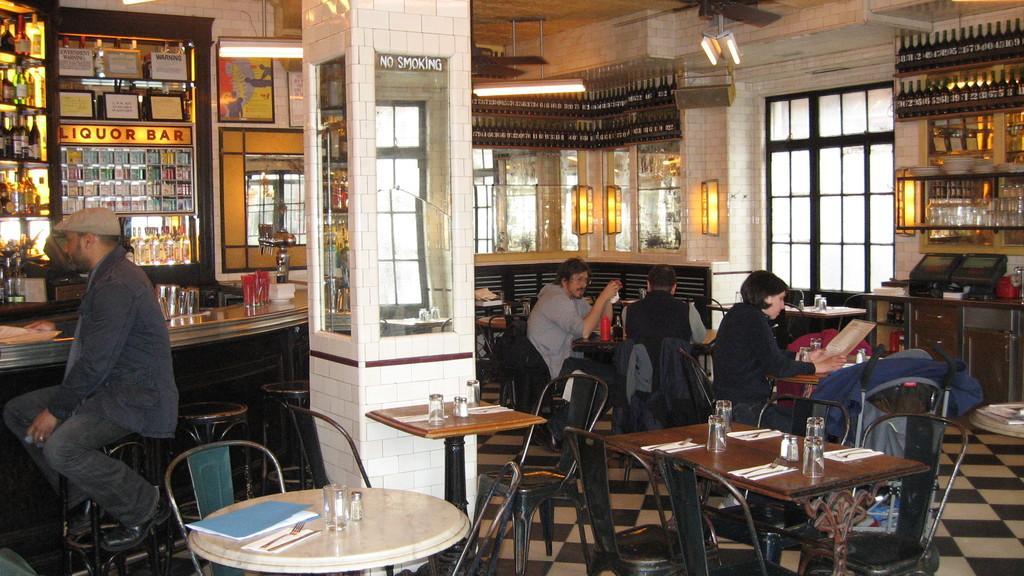Could you give a brief overview of what you see in this image? This is a picture of a bar. Here we can see table and chairs with glasses on it. We can few people sitting on the chairs. This is a window. This is a floor. These are the bottles in a rack. This is a no smoking notice board. 